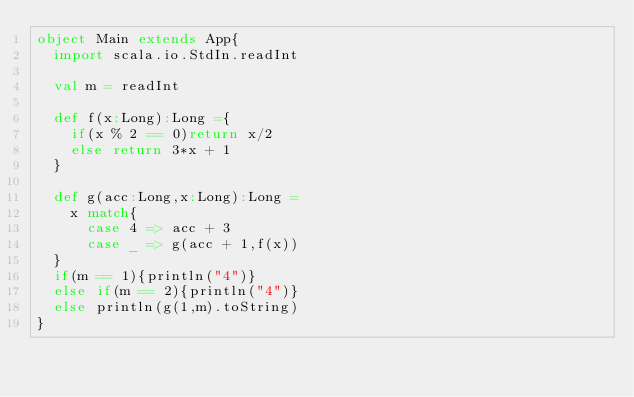Convert code to text. <code><loc_0><loc_0><loc_500><loc_500><_Scala_>object Main extends App{
  import scala.io.StdIn.readInt
  
  val m = readInt

  def f(x:Long):Long ={
  	if(x % 2 == 0)return x/2
    else return 3*x + 1
  }
  
  def g(acc:Long,x:Long):Long =
  	x match{
      case 4 => acc + 3
      case _ => g(acc + 1,f(x))
  }
  if(m == 1){println("4")}
  else if(m == 2){println("4")}
  else println(g(1,m).toString)
}
</code> 